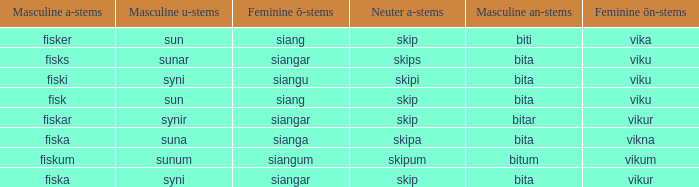What is the masculine u form for the old Swedish word with a neuter a form of skipum? Sunum. 